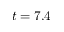<formula> <loc_0><loc_0><loc_500><loc_500>t = 7 . 4</formula> 